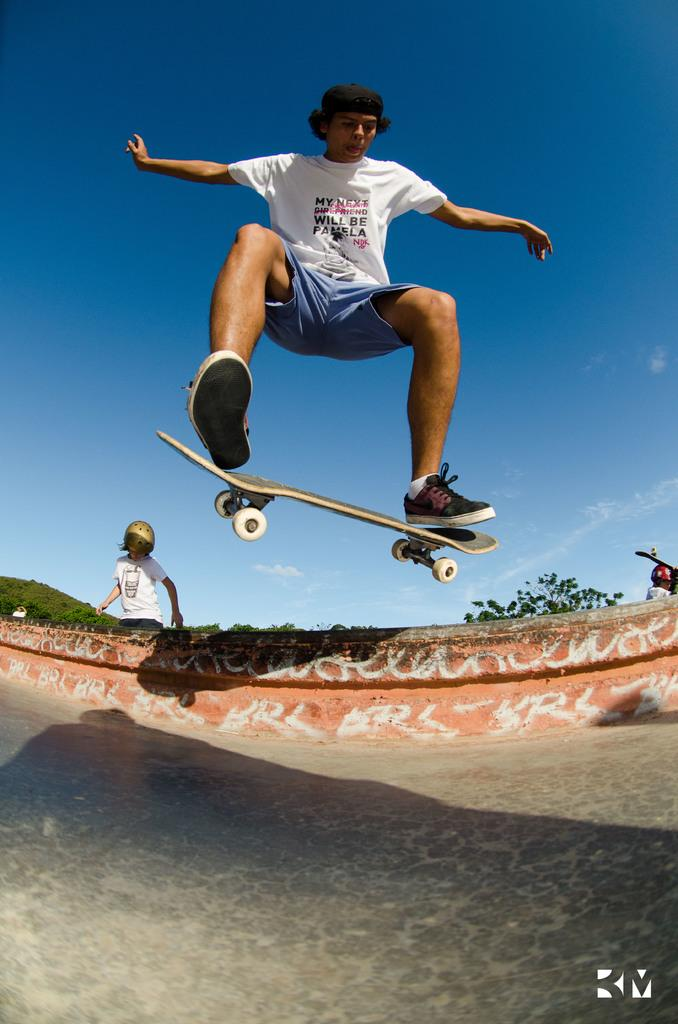What activity is the person in the image engaged in? The person is doing skating in the image. What is the terrain like where the person is skating? The person is on a slope. Can you describe the surroundings in the image? There are people visible in the background of the image. What type of account does the person have with the bat in the image? There is no bat or account present in the image; it features a person skating on a slope with people visible in the background. 